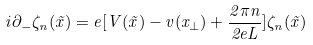<formula> <loc_0><loc_0><loc_500><loc_500>i \partial _ { - } \zeta _ { n } ( \vec { x } ) = e [ V ( \vec { x } ) - v ( x _ { \perp } ) + \frac { 2 \pi n } { 2 e L } ] \zeta _ { n } ( \vec { x } )</formula> 